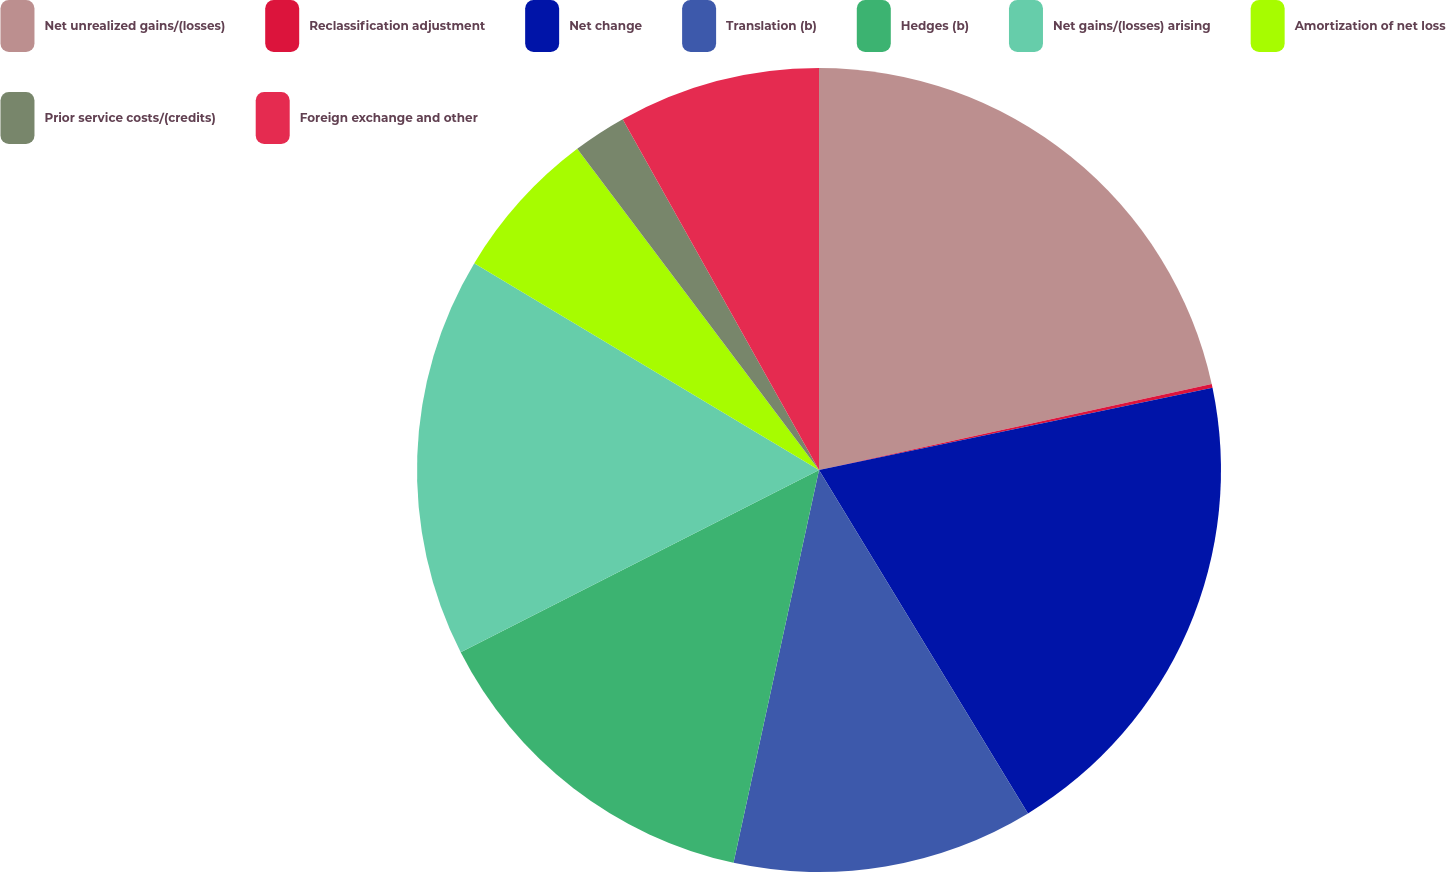Convert chart. <chart><loc_0><loc_0><loc_500><loc_500><pie_chart><fcel>Net unrealized gains/(losses)<fcel>Reclassification adjustment<fcel>Net change<fcel>Translation (b)<fcel>Hedges (b)<fcel>Net gains/(losses) arising<fcel>Amortization of net loss<fcel>Prior service costs/(credits)<fcel>Foreign exchange and other<nl><fcel>21.57%<fcel>0.15%<fcel>19.58%<fcel>12.11%<fcel>14.1%<fcel>16.09%<fcel>6.13%<fcel>2.15%<fcel>8.12%<nl></chart> 